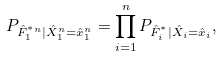<formula> <loc_0><loc_0><loc_500><loc_500>P _ { \hat { F } _ { 1 } ^ { ^ { * } n } | \hat { X } _ { 1 } ^ { n } = \hat { x } _ { 1 } ^ { n } } = \prod _ { i = 1 } ^ { n } P _ { \hat { F } _ { i } ^ { ^ { * } } | \hat { X } _ { i } = \hat { x } _ { i } } ,</formula> 